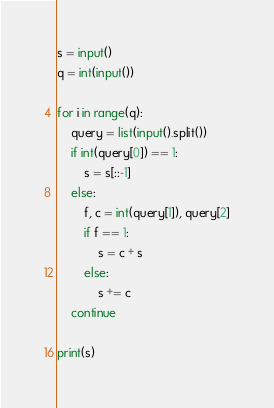<code> <loc_0><loc_0><loc_500><loc_500><_Python_>s = input()
q = int(input())

for i in range(q):
    query = list(input().split())
    if int(query[0]) == 1:
        s = s[::-1]
    else:
        f, c = int(query[1]), query[2]
        if f == 1:
            s = c + s
        else:
            s += c
    continue

print(s)
</code> 